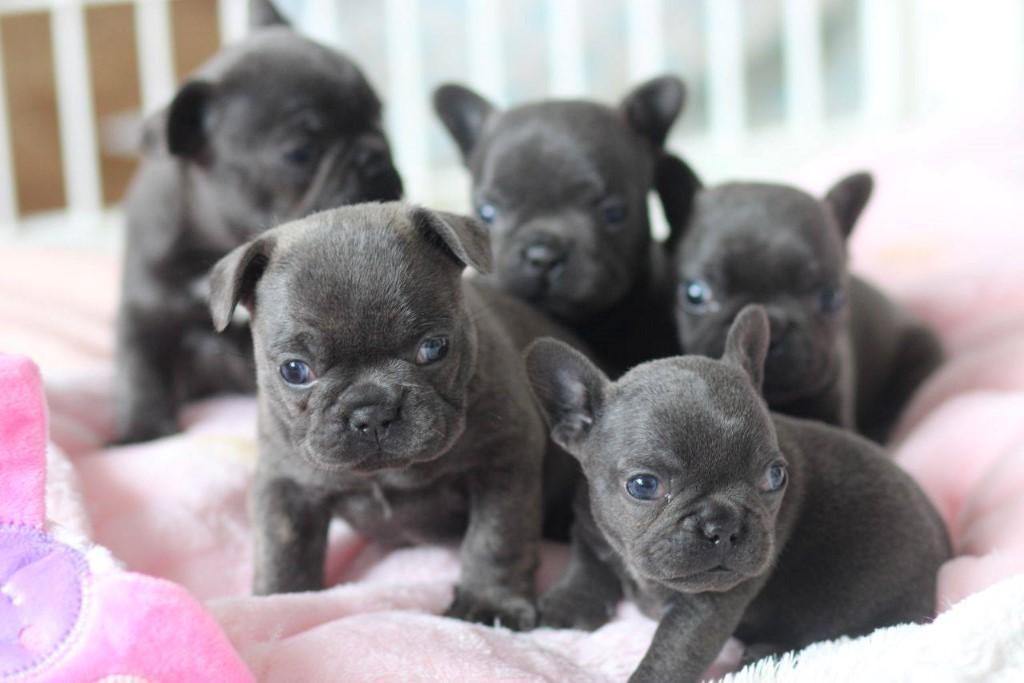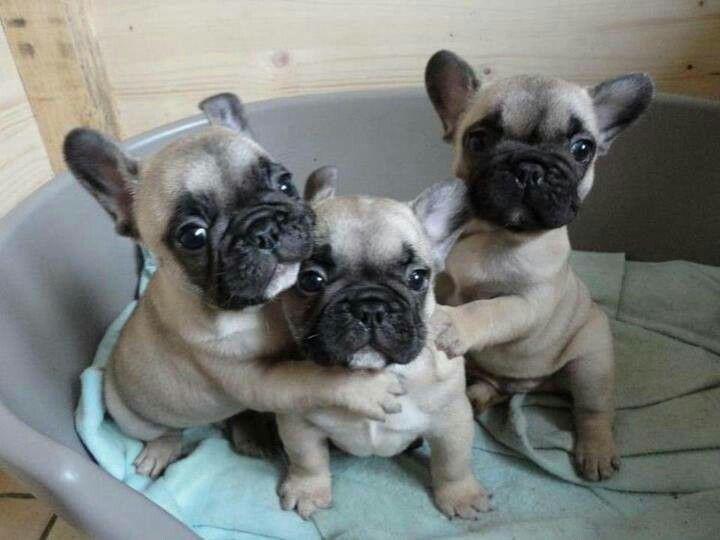The first image is the image on the left, the second image is the image on the right. Analyze the images presented: Is the assertion "There are two dogs in the left image." valid? Answer yes or no. No. The first image is the image on the left, the second image is the image on the right. Evaluate the accuracy of this statement regarding the images: "The left image contains exactly two dogs.". Is it true? Answer yes or no. No. 